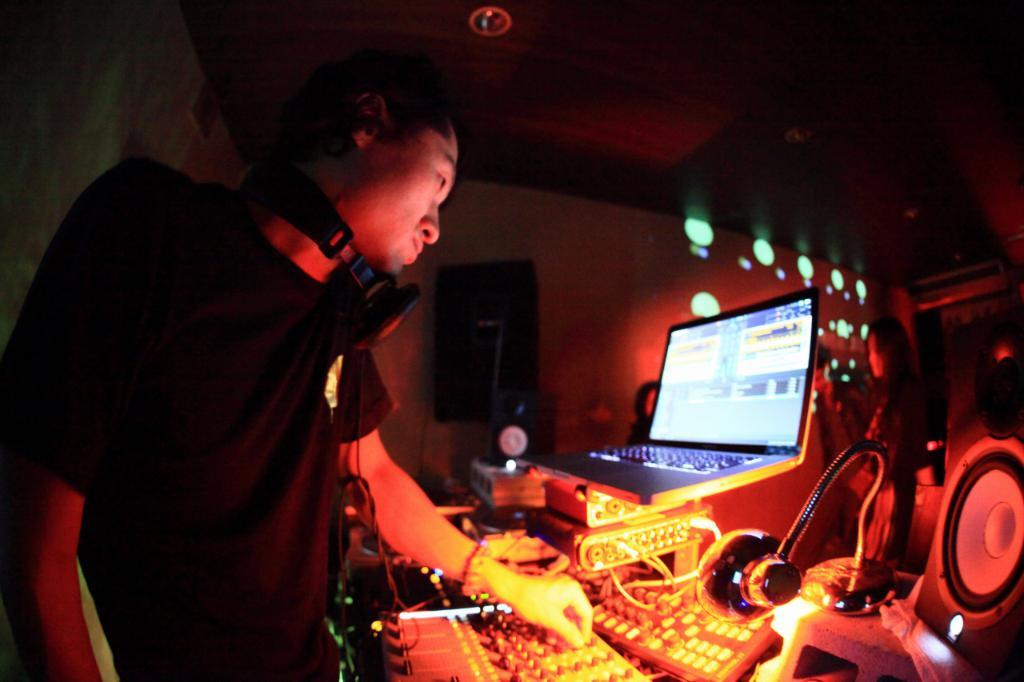What is the main subject of the image? There is a person standing in the image. What electronic devices are visible in the image? There are speakers and a laptop in the image. What type of lighting is present in the image? There is a lamp in the image, and there are lights in the background. Can you describe the group of people in the background? There is a group of people in the background of the image. What type of dinner is being served in the image? There is no dinner present in the image. How does the person in the image express disgust? There is no indication of disgust in the image; the person is simply standing. 